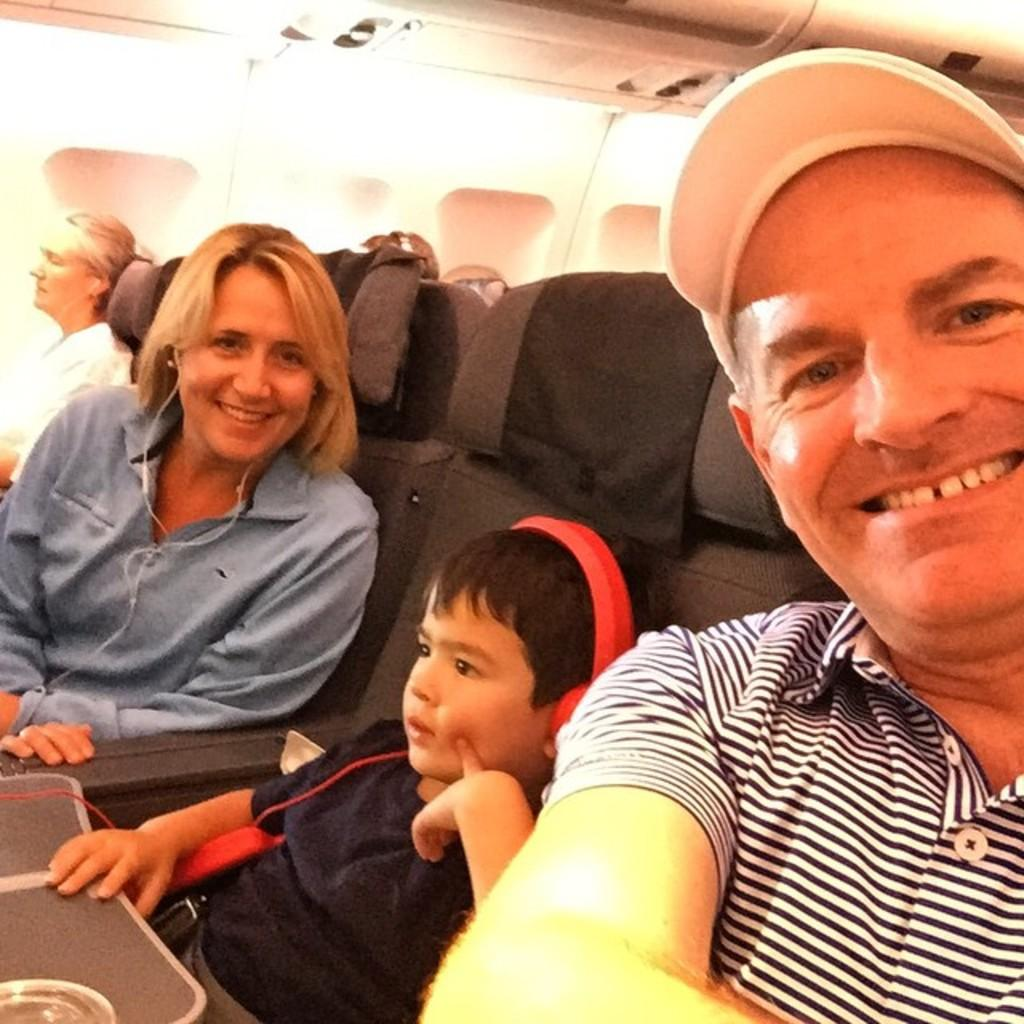How many people are present in the image? There are three people in the image: a man, a woman, and a child. What are the people in the image doing? The people are seated in a plane. Can you describe the setting in which the people are located? The people are seated in a plane, which suggests they are traveling or on a flight. What type of desk can be seen in the image? There is no desk present in the image; it features a man, a woman, and a child seated in a plane. What kind of attraction is visible in the background of the image? There is no attraction visible in the image; it only shows the people seated in a plane. 